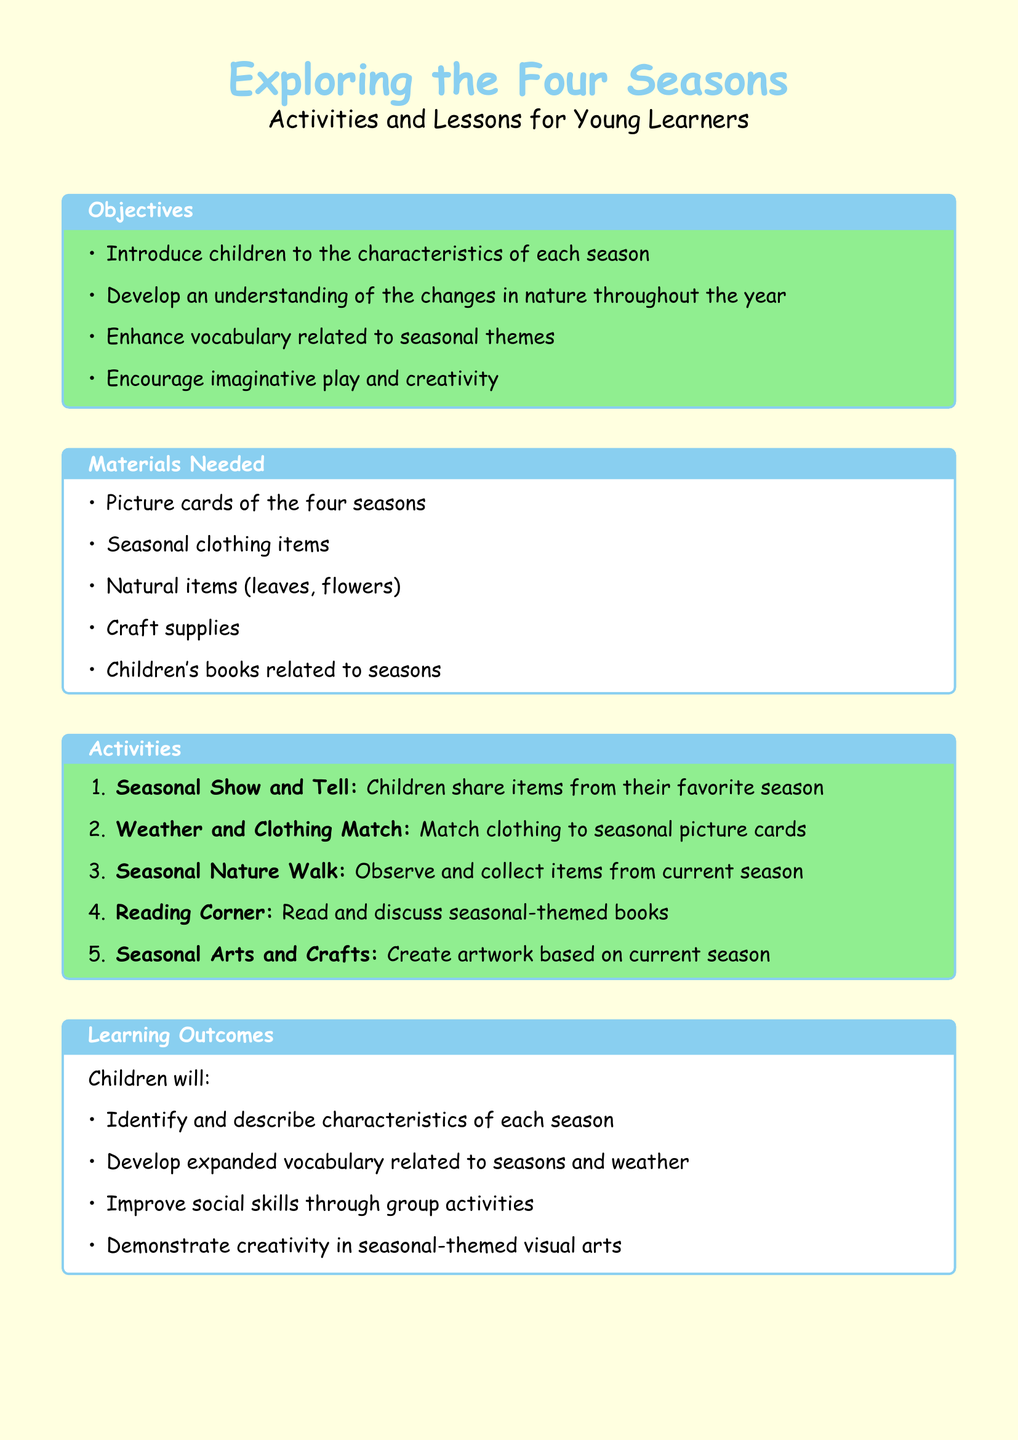What is the title of the lesson plan? The title is prominently presented at the top of the document, introduced by the text formatting applied.
Answer: Exploring the Four Seasons How many objectives are listed in the lesson plan? The number of objectives can be counted from the bulleted list provided in the objectives section.
Answer: Four What activity involves sharing items from a favorite season? The activity description indicates that children will share items related to their experiences of different seasons.
Answer: Seasonal Show and Tell What materials are needed for the activities? The materials required for the activities are clearly outlined in the materials section of the document.
Answer: Picture cards of the four seasons What is one of the learning outcomes for children? The learning outcomes are summarized in the bulleted list after the activities, focusing on children's development.
Answer: Identify and describe characteristics of each season How will children’s participation be assessed? The assessment section lists various methods of evaluation for observing children's participation and engagement.
Answer: Observation of participation and engagement Which color is used for the background of the document? The background color is specified in the document's page settings as part of its aesthetic choices.
Answer: Light yellow What type of crafts do children create based on? The activities listed provide a framework for understanding the theme of the arts and crafts conducted.
Answer: Current season 